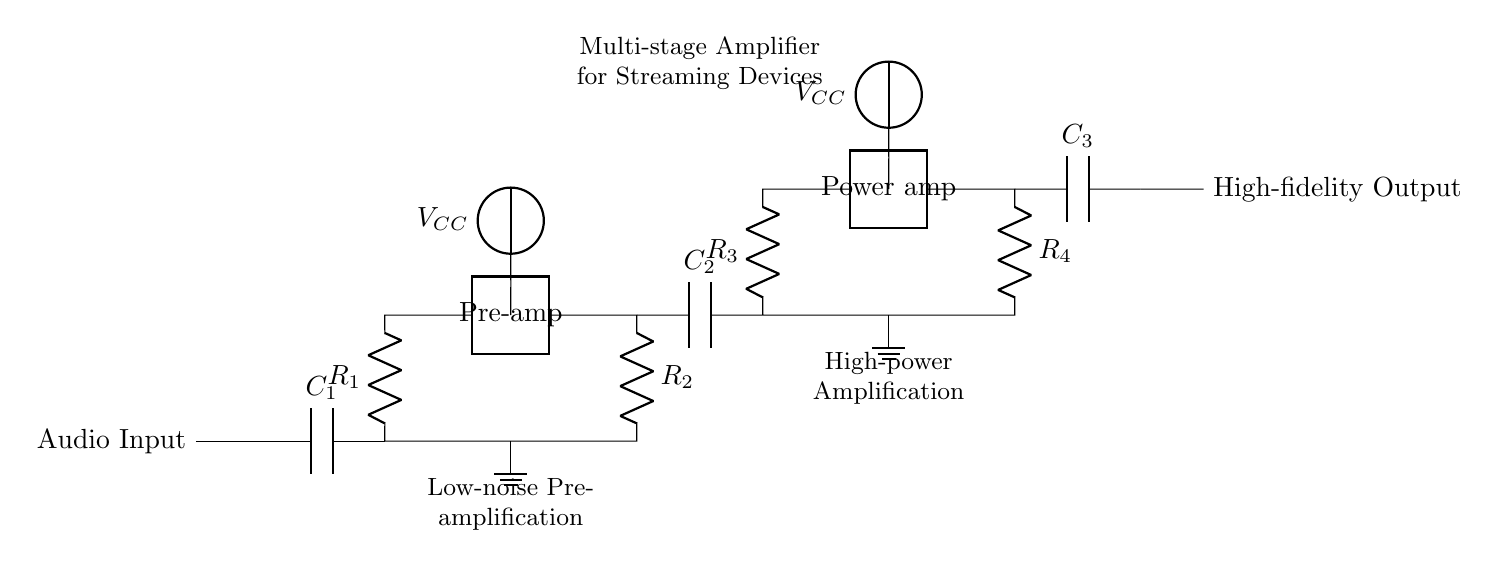What component couples the first and second stage? The component that couples the first and second stage is the capacitor labeled C2, which allows AC signals to pass while blocking DC signals.
Answer: C2 What is the purpose of R1 in the circuit? R1 serves as a load resistor in the pre-amplifier stage, helping to control the signal gain and set the input impedance.
Answer: Load resistor What voltage is provided to the pre-amp stage? The pre-amp stage receives a voltage supply labeled VCC, which is typically used to provide the necessary power for amplification.
Answer: VCC How many stages are present in this amplifier circuit? The circuit features two stages: a pre-amplifier stage and a power amplifier stage, which work together to amplify the audio signal.
Answer: Two stages What type of amplification does the second stage provide? The second stage is designated as a power amplifier, which is intended to deliver high power output to drive speakers or other loads.
Answer: Power amplification How are the ground connections represented in the circuit? Ground connections in the circuit are visually represented by nodes labeled with a ground symbol, indicating a common reference point for the circuit.
Answer: Ground symbol 